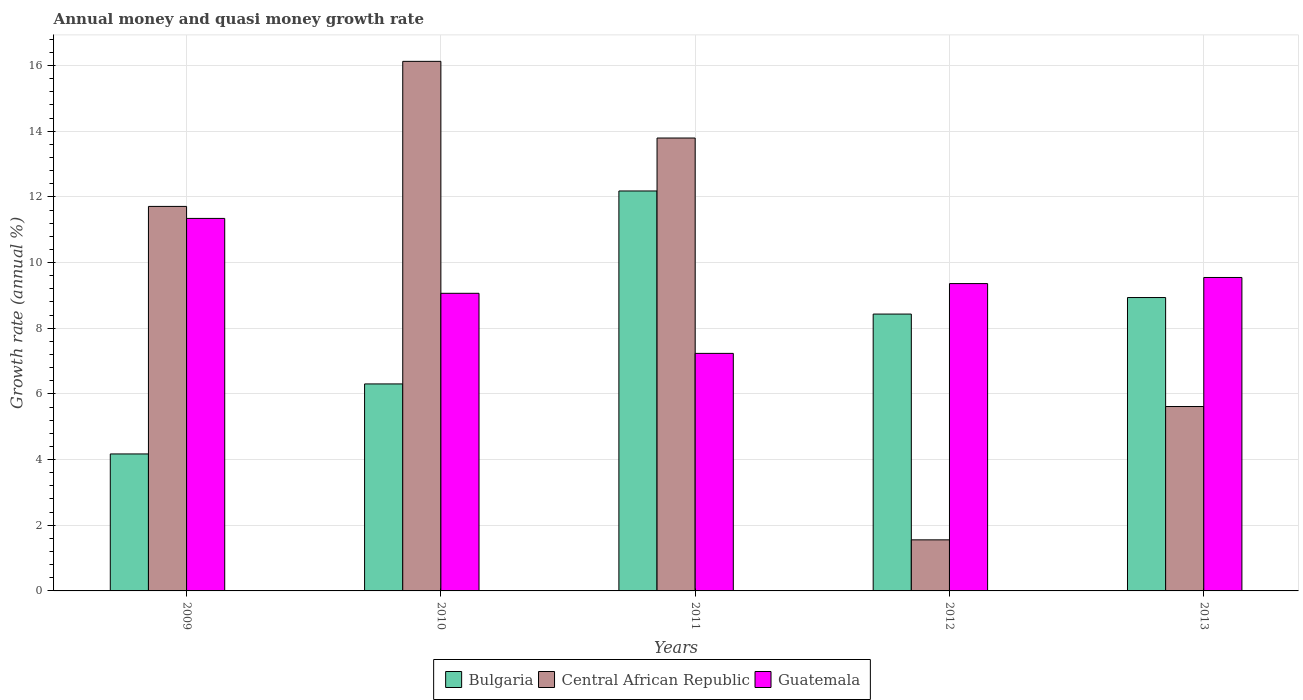How many different coloured bars are there?
Your answer should be very brief. 3. How many groups of bars are there?
Your answer should be very brief. 5. Are the number of bars on each tick of the X-axis equal?
Make the answer very short. Yes. What is the label of the 4th group of bars from the left?
Give a very brief answer. 2012. What is the growth rate in Guatemala in 2010?
Keep it short and to the point. 9.06. Across all years, what is the maximum growth rate in Central African Republic?
Your answer should be very brief. 16.13. Across all years, what is the minimum growth rate in Bulgaria?
Give a very brief answer. 4.17. In which year was the growth rate in Guatemala maximum?
Your answer should be very brief. 2009. In which year was the growth rate in Guatemala minimum?
Offer a terse response. 2011. What is the total growth rate in Guatemala in the graph?
Offer a terse response. 46.55. What is the difference between the growth rate in Guatemala in 2011 and that in 2012?
Your answer should be very brief. -2.13. What is the difference between the growth rate in Central African Republic in 2010 and the growth rate in Guatemala in 2012?
Make the answer very short. 6.77. What is the average growth rate in Bulgaria per year?
Your answer should be very brief. 8.01. In the year 2010, what is the difference between the growth rate in Bulgaria and growth rate in Guatemala?
Give a very brief answer. -2.76. What is the ratio of the growth rate in Guatemala in 2009 to that in 2013?
Keep it short and to the point. 1.19. Is the growth rate in Bulgaria in 2011 less than that in 2012?
Provide a short and direct response. No. What is the difference between the highest and the second highest growth rate in Bulgaria?
Your answer should be very brief. 3.25. What is the difference between the highest and the lowest growth rate in Bulgaria?
Your answer should be compact. 8.01. What does the 3rd bar from the left in 2009 represents?
Your answer should be very brief. Guatemala. What does the 2nd bar from the right in 2010 represents?
Provide a succinct answer. Central African Republic. Are all the bars in the graph horizontal?
Ensure brevity in your answer.  No. How many years are there in the graph?
Ensure brevity in your answer.  5. What is the difference between two consecutive major ticks on the Y-axis?
Your answer should be compact. 2. Are the values on the major ticks of Y-axis written in scientific E-notation?
Your response must be concise. No. Does the graph contain any zero values?
Offer a very short reply. No. Does the graph contain grids?
Offer a very short reply. Yes. How many legend labels are there?
Your answer should be very brief. 3. What is the title of the graph?
Provide a succinct answer. Annual money and quasi money growth rate. What is the label or title of the Y-axis?
Offer a terse response. Growth rate (annual %). What is the Growth rate (annual %) in Bulgaria in 2009?
Offer a terse response. 4.17. What is the Growth rate (annual %) of Central African Republic in 2009?
Your response must be concise. 11.71. What is the Growth rate (annual %) of Guatemala in 2009?
Your answer should be very brief. 11.35. What is the Growth rate (annual %) in Bulgaria in 2010?
Give a very brief answer. 6.3. What is the Growth rate (annual %) in Central African Republic in 2010?
Offer a very short reply. 16.13. What is the Growth rate (annual %) in Guatemala in 2010?
Your answer should be compact. 9.06. What is the Growth rate (annual %) of Bulgaria in 2011?
Provide a short and direct response. 12.18. What is the Growth rate (annual %) in Central African Republic in 2011?
Provide a succinct answer. 13.79. What is the Growth rate (annual %) in Guatemala in 2011?
Your response must be concise. 7.23. What is the Growth rate (annual %) of Bulgaria in 2012?
Offer a terse response. 8.43. What is the Growth rate (annual %) in Central African Republic in 2012?
Ensure brevity in your answer.  1.56. What is the Growth rate (annual %) in Guatemala in 2012?
Make the answer very short. 9.36. What is the Growth rate (annual %) of Bulgaria in 2013?
Keep it short and to the point. 8.94. What is the Growth rate (annual %) of Central African Republic in 2013?
Offer a terse response. 5.62. What is the Growth rate (annual %) in Guatemala in 2013?
Keep it short and to the point. 9.55. Across all years, what is the maximum Growth rate (annual %) of Bulgaria?
Ensure brevity in your answer.  12.18. Across all years, what is the maximum Growth rate (annual %) in Central African Republic?
Provide a succinct answer. 16.13. Across all years, what is the maximum Growth rate (annual %) of Guatemala?
Ensure brevity in your answer.  11.35. Across all years, what is the minimum Growth rate (annual %) in Bulgaria?
Ensure brevity in your answer.  4.17. Across all years, what is the minimum Growth rate (annual %) of Central African Republic?
Make the answer very short. 1.56. Across all years, what is the minimum Growth rate (annual %) in Guatemala?
Provide a succinct answer. 7.23. What is the total Growth rate (annual %) in Bulgaria in the graph?
Your answer should be very brief. 40.03. What is the total Growth rate (annual %) of Central African Republic in the graph?
Make the answer very short. 48.81. What is the total Growth rate (annual %) in Guatemala in the graph?
Give a very brief answer. 46.55. What is the difference between the Growth rate (annual %) in Bulgaria in 2009 and that in 2010?
Keep it short and to the point. -2.13. What is the difference between the Growth rate (annual %) of Central African Republic in 2009 and that in 2010?
Provide a short and direct response. -4.42. What is the difference between the Growth rate (annual %) in Guatemala in 2009 and that in 2010?
Offer a terse response. 2.28. What is the difference between the Growth rate (annual %) in Bulgaria in 2009 and that in 2011?
Provide a short and direct response. -8.01. What is the difference between the Growth rate (annual %) in Central African Republic in 2009 and that in 2011?
Offer a terse response. -2.08. What is the difference between the Growth rate (annual %) in Guatemala in 2009 and that in 2011?
Provide a short and direct response. 4.11. What is the difference between the Growth rate (annual %) of Bulgaria in 2009 and that in 2012?
Provide a short and direct response. -4.26. What is the difference between the Growth rate (annual %) of Central African Republic in 2009 and that in 2012?
Provide a short and direct response. 10.16. What is the difference between the Growth rate (annual %) in Guatemala in 2009 and that in 2012?
Keep it short and to the point. 1.99. What is the difference between the Growth rate (annual %) of Bulgaria in 2009 and that in 2013?
Your answer should be compact. -4.76. What is the difference between the Growth rate (annual %) in Central African Republic in 2009 and that in 2013?
Make the answer very short. 6.09. What is the difference between the Growth rate (annual %) of Guatemala in 2009 and that in 2013?
Keep it short and to the point. 1.8. What is the difference between the Growth rate (annual %) of Bulgaria in 2010 and that in 2011?
Provide a short and direct response. -5.88. What is the difference between the Growth rate (annual %) in Central African Republic in 2010 and that in 2011?
Your answer should be very brief. 2.33. What is the difference between the Growth rate (annual %) in Guatemala in 2010 and that in 2011?
Your response must be concise. 1.83. What is the difference between the Growth rate (annual %) of Bulgaria in 2010 and that in 2012?
Provide a short and direct response. -2.13. What is the difference between the Growth rate (annual %) of Central African Republic in 2010 and that in 2012?
Your response must be concise. 14.57. What is the difference between the Growth rate (annual %) in Guatemala in 2010 and that in 2012?
Provide a succinct answer. -0.3. What is the difference between the Growth rate (annual %) in Bulgaria in 2010 and that in 2013?
Your response must be concise. -2.63. What is the difference between the Growth rate (annual %) of Central African Republic in 2010 and that in 2013?
Keep it short and to the point. 10.51. What is the difference between the Growth rate (annual %) of Guatemala in 2010 and that in 2013?
Your answer should be compact. -0.48. What is the difference between the Growth rate (annual %) of Bulgaria in 2011 and that in 2012?
Your answer should be very brief. 3.75. What is the difference between the Growth rate (annual %) in Central African Republic in 2011 and that in 2012?
Give a very brief answer. 12.24. What is the difference between the Growth rate (annual %) of Guatemala in 2011 and that in 2012?
Keep it short and to the point. -2.13. What is the difference between the Growth rate (annual %) in Bulgaria in 2011 and that in 2013?
Your answer should be compact. 3.25. What is the difference between the Growth rate (annual %) in Central African Republic in 2011 and that in 2013?
Offer a very short reply. 8.18. What is the difference between the Growth rate (annual %) in Guatemala in 2011 and that in 2013?
Your answer should be very brief. -2.31. What is the difference between the Growth rate (annual %) of Bulgaria in 2012 and that in 2013?
Your answer should be very brief. -0.5. What is the difference between the Growth rate (annual %) in Central African Republic in 2012 and that in 2013?
Your response must be concise. -4.06. What is the difference between the Growth rate (annual %) in Guatemala in 2012 and that in 2013?
Offer a terse response. -0.19. What is the difference between the Growth rate (annual %) in Bulgaria in 2009 and the Growth rate (annual %) in Central African Republic in 2010?
Offer a terse response. -11.96. What is the difference between the Growth rate (annual %) in Bulgaria in 2009 and the Growth rate (annual %) in Guatemala in 2010?
Your answer should be compact. -4.89. What is the difference between the Growth rate (annual %) of Central African Republic in 2009 and the Growth rate (annual %) of Guatemala in 2010?
Keep it short and to the point. 2.65. What is the difference between the Growth rate (annual %) of Bulgaria in 2009 and the Growth rate (annual %) of Central African Republic in 2011?
Ensure brevity in your answer.  -9.62. What is the difference between the Growth rate (annual %) in Bulgaria in 2009 and the Growth rate (annual %) in Guatemala in 2011?
Ensure brevity in your answer.  -3.06. What is the difference between the Growth rate (annual %) of Central African Republic in 2009 and the Growth rate (annual %) of Guatemala in 2011?
Ensure brevity in your answer.  4.48. What is the difference between the Growth rate (annual %) of Bulgaria in 2009 and the Growth rate (annual %) of Central African Republic in 2012?
Give a very brief answer. 2.62. What is the difference between the Growth rate (annual %) in Bulgaria in 2009 and the Growth rate (annual %) in Guatemala in 2012?
Your answer should be very brief. -5.19. What is the difference between the Growth rate (annual %) of Central African Republic in 2009 and the Growth rate (annual %) of Guatemala in 2012?
Your answer should be very brief. 2.35. What is the difference between the Growth rate (annual %) in Bulgaria in 2009 and the Growth rate (annual %) in Central African Republic in 2013?
Offer a very short reply. -1.44. What is the difference between the Growth rate (annual %) of Bulgaria in 2009 and the Growth rate (annual %) of Guatemala in 2013?
Make the answer very short. -5.37. What is the difference between the Growth rate (annual %) in Central African Republic in 2009 and the Growth rate (annual %) in Guatemala in 2013?
Offer a terse response. 2.16. What is the difference between the Growth rate (annual %) in Bulgaria in 2010 and the Growth rate (annual %) in Central African Republic in 2011?
Your answer should be very brief. -7.49. What is the difference between the Growth rate (annual %) of Bulgaria in 2010 and the Growth rate (annual %) of Guatemala in 2011?
Offer a terse response. -0.93. What is the difference between the Growth rate (annual %) of Central African Republic in 2010 and the Growth rate (annual %) of Guatemala in 2011?
Offer a very short reply. 8.89. What is the difference between the Growth rate (annual %) of Bulgaria in 2010 and the Growth rate (annual %) of Central African Republic in 2012?
Your answer should be very brief. 4.75. What is the difference between the Growth rate (annual %) in Bulgaria in 2010 and the Growth rate (annual %) in Guatemala in 2012?
Offer a terse response. -3.06. What is the difference between the Growth rate (annual %) of Central African Republic in 2010 and the Growth rate (annual %) of Guatemala in 2012?
Offer a very short reply. 6.77. What is the difference between the Growth rate (annual %) in Bulgaria in 2010 and the Growth rate (annual %) in Central African Republic in 2013?
Make the answer very short. 0.69. What is the difference between the Growth rate (annual %) of Bulgaria in 2010 and the Growth rate (annual %) of Guatemala in 2013?
Ensure brevity in your answer.  -3.24. What is the difference between the Growth rate (annual %) of Central African Republic in 2010 and the Growth rate (annual %) of Guatemala in 2013?
Make the answer very short. 6.58. What is the difference between the Growth rate (annual %) of Bulgaria in 2011 and the Growth rate (annual %) of Central African Republic in 2012?
Give a very brief answer. 10.63. What is the difference between the Growth rate (annual %) in Bulgaria in 2011 and the Growth rate (annual %) in Guatemala in 2012?
Your response must be concise. 2.82. What is the difference between the Growth rate (annual %) of Central African Republic in 2011 and the Growth rate (annual %) of Guatemala in 2012?
Your response must be concise. 4.43. What is the difference between the Growth rate (annual %) of Bulgaria in 2011 and the Growth rate (annual %) of Central African Republic in 2013?
Your answer should be very brief. 6.57. What is the difference between the Growth rate (annual %) in Bulgaria in 2011 and the Growth rate (annual %) in Guatemala in 2013?
Give a very brief answer. 2.63. What is the difference between the Growth rate (annual %) in Central African Republic in 2011 and the Growth rate (annual %) in Guatemala in 2013?
Your answer should be very brief. 4.25. What is the difference between the Growth rate (annual %) of Bulgaria in 2012 and the Growth rate (annual %) of Central African Republic in 2013?
Ensure brevity in your answer.  2.82. What is the difference between the Growth rate (annual %) in Bulgaria in 2012 and the Growth rate (annual %) in Guatemala in 2013?
Give a very brief answer. -1.11. What is the difference between the Growth rate (annual %) in Central African Republic in 2012 and the Growth rate (annual %) in Guatemala in 2013?
Make the answer very short. -7.99. What is the average Growth rate (annual %) in Bulgaria per year?
Your response must be concise. 8.01. What is the average Growth rate (annual %) of Central African Republic per year?
Offer a very short reply. 9.76. What is the average Growth rate (annual %) of Guatemala per year?
Provide a short and direct response. 9.31. In the year 2009, what is the difference between the Growth rate (annual %) in Bulgaria and Growth rate (annual %) in Central African Republic?
Offer a very short reply. -7.54. In the year 2009, what is the difference between the Growth rate (annual %) of Bulgaria and Growth rate (annual %) of Guatemala?
Give a very brief answer. -7.17. In the year 2009, what is the difference between the Growth rate (annual %) of Central African Republic and Growth rate (annual %) of Guatemala?
Provide a short and direct response. 0.37. In the year 2010, what is the difference between the Growth rate (annual %) in Bulgaria and Growth rate (annual %) in Central African Republic?
Make the answer very short. -9.82. In the year 2010, what is the difference between the Growth rate (annual %) in Bulgaria and Growth rate (annual %) in Guatemala?
Ensure brevity in your answer.  -2.76. In the year 2010, what is the difference between the Growth rate (annual %) of Central African Republic and Growth rate (annual %) of Guatemala?
Ensure brevity in your answer.  7.06. In the year 2011, what is the difference between the Growth rate (annual %) of Bulgaria and Growth rate (annual %) of Central African Republic?
Your answer should be very brief. -1.61. In the year 2011, what is the difference between the Growth rate (annual %) in Bulgaria and Growth rate (annual %) in Guatemala?
Your response must be concise. 4.95. In the year 2011, what is the difference between the Growth rate (annual %) of Central African Republic and Growth rate (annual %) of Guatemala?
Offer a terse response. 6.56. In the year 2012, what is the difference between the Growth rate (annual %) in Bulgaria and Growth rate (annual %) in Central African Republic?
Your answer should be compact. 6.88. In the year 2012, what is the difference between the Growth rate (annual %) in Bulgaria and Growth rate (annual %) in Guatemala?
Provide a succinct answer. -0.93. In the year 2012, what is the difference between the Growth rate (annual %) of Central African Republic and Growth rate (annual %) of Guatemala?
Provide a short and direct response. -7.81. In the year 2013, what is the difference between the Growth rate (annual %) of Bulgaria and Growth rate (annual %) of Central African Republic?
Provide a short and direct response. 3.32. In the year 2013, what is the difference between the Growth rate (annual %) in Bulgaria and Growth rate (annual %) in Guatemala?
Keep it short and to the point. -0.61. In the year 2013, what is the difference between the Growth rate (annual %) in Central African Republic and Growth rate (annual %) in Guatemala?
Offer a terse response. -3.93. What is the ratio of the Growth rate (annual %) of Bulgaria in 2009 to that in 2010?
Your answer should be compact. 0.66. What is the ratio of the Growth rate (annual %) in Central African Republic in 2009 to that in 2010?
Make the answer very short. 0.73. What is the ratio of the Growth rate (annual %) in Guatemala in 2009 to that in 2010?
Your answer should be very brief. 1.25. What is the ratio of the Growth rate (annual %) in Bulgaria in 2009 to that in 2011?
Provide a succinct answer. 0.34. What is the ratio of the Growth rate (annual %) in Central African Republic in 2009 to that in 2011?
Your answer should be very brief. 0.85. What is the ratio of the Growth rate (annual %) in Guatemala in 2009 to that in 2011?
Offer a very short reply. 1.57. What is the ratio of the Growth rate (annual %) in Bulgaria in 2009 to that in 2012?
Your response must be concise. 0.49. What is the ratio of the Growth rate (annual %) in Central African Republic in 2009 to that in 2012?
Make the answer very short. 7.53. What is the ratio of the Growth rate (annual %) of Guatemala in 2009 to that in 2012?
Your response must be concise. 1.21. What is the ratio of the Growth rate (annual %) in Bulgaria in 2009 to that in 2013?
Your answer should be compact. 0.47. What is the ratio of the Growth rate (annual %) of Central African Republic in 2009 to that in 2013?
Provide a short and direct response. 2.09. What is the ratio of the Growth rate (annual %) in Guatemala in 2009 to that in 2013?
Your response must be concise. 1.19. What is the ratio of the Growth rate (annual %) of Bulgaria in 2010 to that in 2011?
Your response must be concise. 0.52. What is the ratio of the Growth rate (annual %) of Central African Republic in 2010 to that in 2011?
Your response must be concise. 1.17. What is the ratio of the Growth rate (annual %) of Guatemala in 2010 to that in 2011?
Offer a very short reply. 1.25. What is the ratio of the Growth rate (annual %) of Bulgaria in 2010 to that in 2012?
Give a very brief answer. 0.75. What is the ratio of the Growth rate (annual %) of Central African Republic in 2010 to that in 2012?
Keep it short and to the point. 10.37. What is the ratio of the Growth rate (annual %) in Guatemala in 2010 to that in 2012?
Provide a short and direct response. 0.97. What is the ratio of the Growth rate (annual %) of Bulgaria in 2010 to that in 2013?
Give a very brief answer. 0.71. What is the ratio of the Growth rate (annual %) in Central African Republic in 2010 to that in 2013?
Your answer should be very brief. 2.87. What is the ratio of the Growth rate (annual %) in Guatemala in 2010 to that in 2013?
Give a very brief answer. 0.95. What is the ratio of the Growth rate (annual %) of Bulgaria in 2011 to that in 2012?
Offer a very short reply. 1.44. What is the ratio of the Growth rate (annual %) of Central African Republic in 2011 to that in 2012?
Ensure brevity in your answer.  8.87. What is the ratio of the Growth rate (annual %) in Guatemala in 2011 to that in 2012?
Provide a short and direct response. 0.77. What is the ratio of the Growth rate (annual %) in Bulgaria in 2011 to that in 2013?
Make the answer very short. 1.36. What is the ratio of the Growth rate (annual %) in Central African Republic in 2011 to that in 2013?
Make the answer very short. 2.46. What is the ratio of the Growth rate (annual %) in Guatemala in 2011 to that in 2013?
Keep it short and to the point. 0.76. What is the ratio of the Growth rate (annual %) of Bulgaria in 2012 to that in 2013?
Offer a very short reply. 0.94. What is the ratio of the Growth rate (annual %) of Central African Republic in 2012 to that in 2013?
Provide a succinct answer. 0.28. What is the ratio of the Growth rate (annual %) in Guatemala in 2012 to that in 2013?
Ensure brevity in your answer.  0.98. What is the difference between the highest and the second highest Growth rate (annual %) of Bulgaria?
Your answer should be very brief. 3.25. What is the difference between the highest and the second highest Growth rate (annual %) of Central African Republic?
Provide a short and direct response. 2.33. What is the difference between the highest and the second highest Growth rate (annual %) of Guatemala?
Your answer should be compact. 1.8. What is the difference between the highest and the lowest Growth rate (annual %) in Bulgaria?
Give a very brief answer. 8.01. What is the difference between the highest and the lowest Growth rate (annual %) of Central African Republic?
Provide a succinct answer. 14.57. What is the difference between the highest and the lowest Growth rate (annual %) in Guatemala?
Offer a terse response. 4.11. 